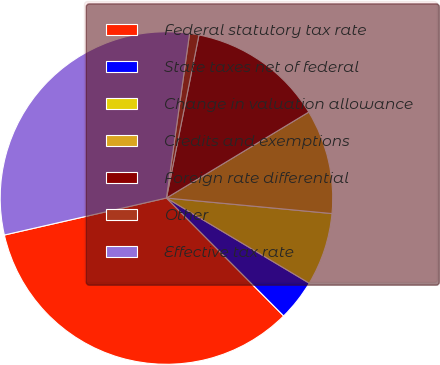Convert chart to OTSL. <chart><loc_0><loc_0><loc_500><loc_500><pie_chart><fcel>Federal statutory tax rate<fcel>State taxes net of federal<fcel>Change in valuation allowance<fcel>Credits and exemptions<fcel>Foreign rate differential<fcel>Other<fcel>Effective tax rate<nl><fcel>33.88%<fcel>3.99%<fcel>7.07%<fcel>10.14%<fcel>13.22%<fcel>0.91%<fcel>30.8%<nl></chart> 